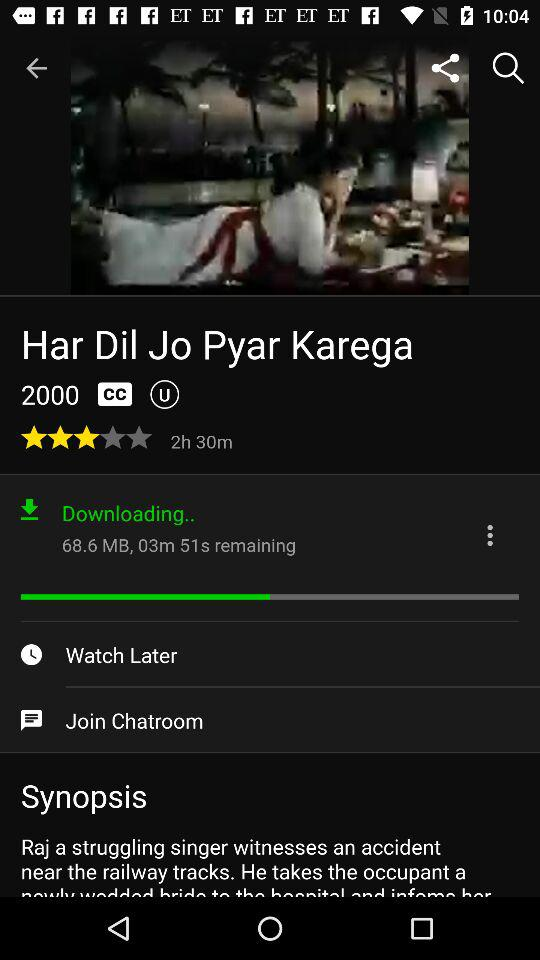What is the duration of the movie? The duration of the movie is 2 hours and 30 minutes. 